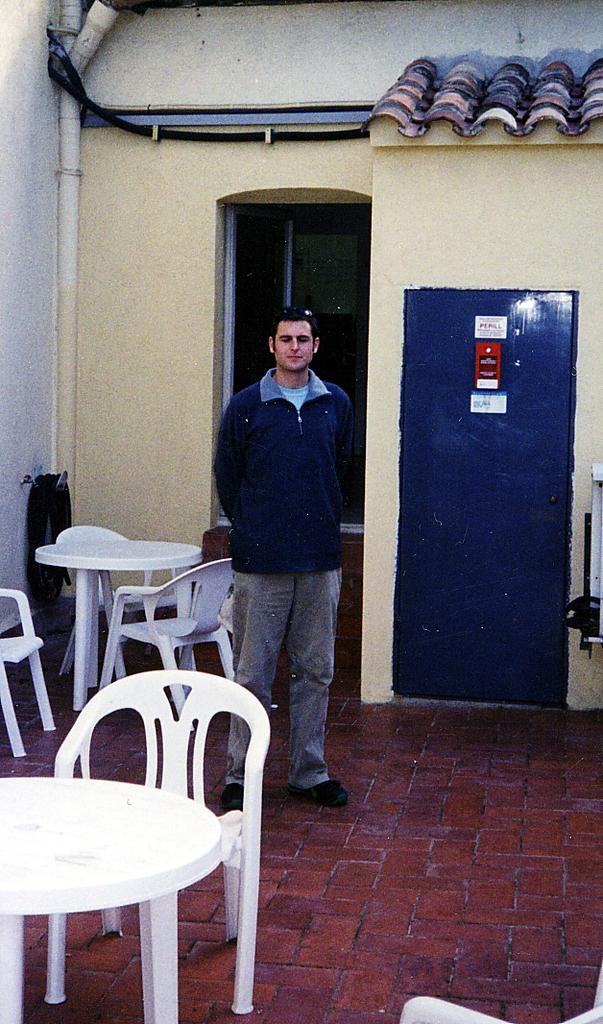What is the person in the image wearing? The person is wearing a blue jacket in the image. What is the person doing in the image? The person is standing in the image. What can be seen in front of the person? There are tables and chairs in front of the person. What can be seen behind the person? There are tables and chairs behind the person. What color is the background wall in the image? The background wall is yellow in color. What type of unit is the person managing in the image? There is no indication in the image that the person is managing a unit or any other type of organization. How many chickens are visible in the image? There are no chickens present in the image. 